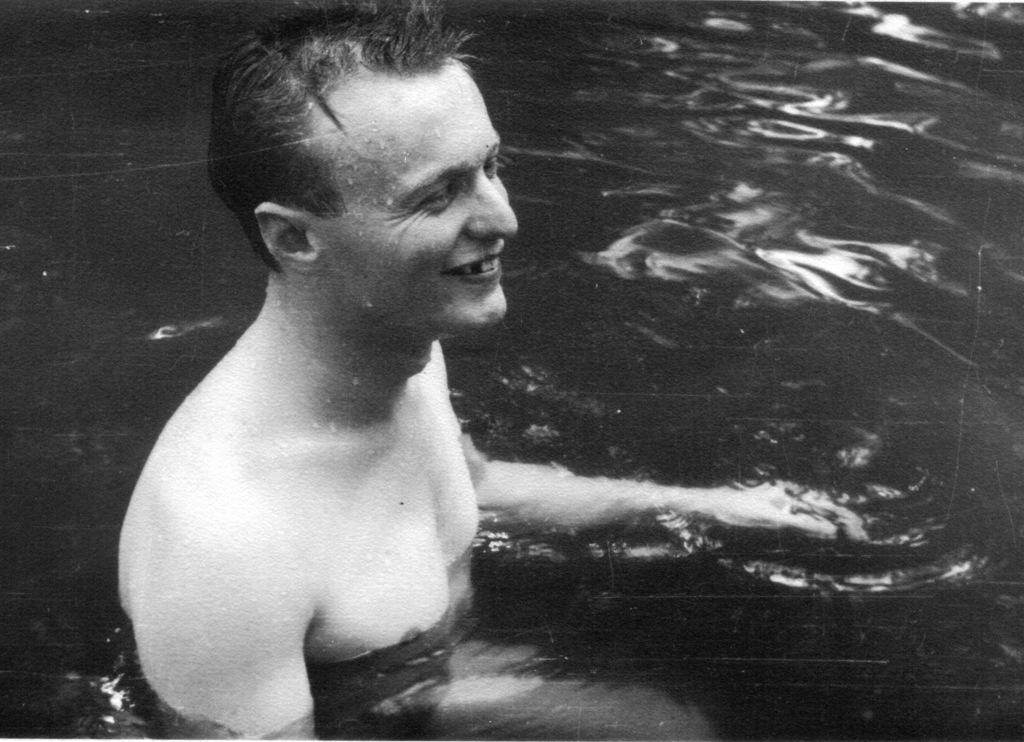What is the man in the image doing? There is a man in the water. How does the man appear to be feeling in the image? The man is smiling. What sense does the man appear to be using while in the water? The image does not provide information about which sense the man is using while in the water. Is the man's grandfather also present in the image? There is no mention of a grandfather in the image. Are there any dolls visible in the image? There is no mention of dolls in the image. 